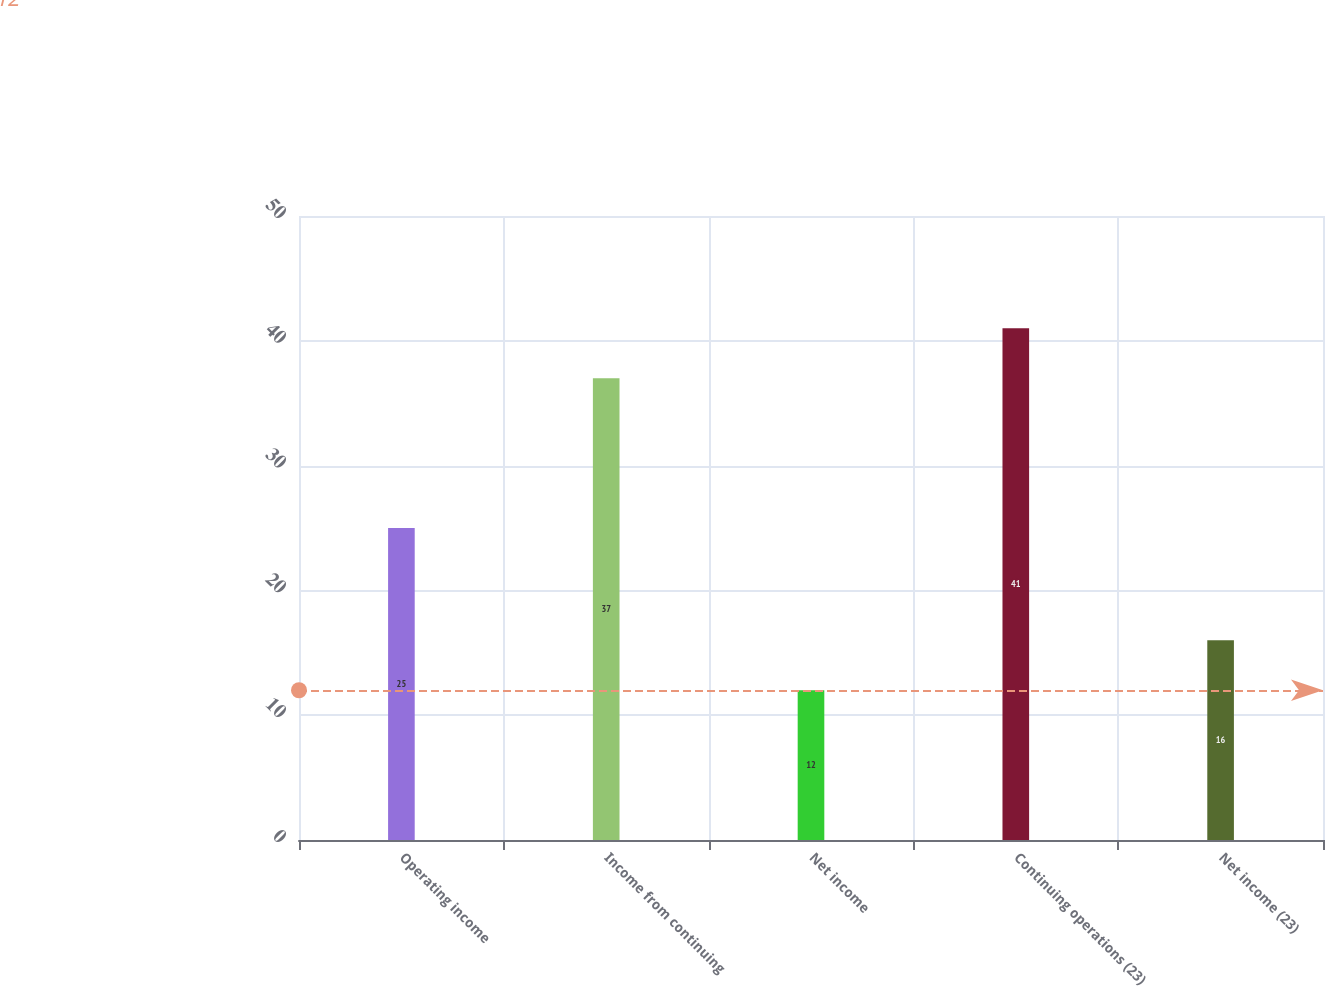Convert chart to OTSL. <chart><loc_0><loc_0><loc_500><loc_500><bar_chart><fcel>Operating income<fcel>Income from continuing<fcel>Net income<fcel>Continuing operations (23)<fcel>Net income (23)<nl><fcel>25<fcel>37<fcel>12<fcel>41<fcel>16<nl></chart> 